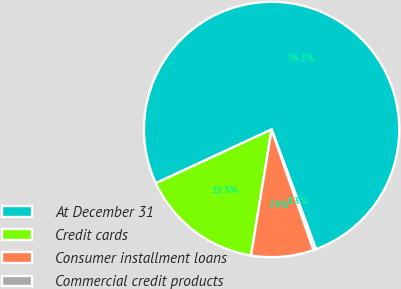Convert chart to OTSL. <chart><loc_0><loc_0><loc_500><loc_500><pie_chart><fcel>At December 31<fcel>Credit cards<fcel>Consumer installment loans<fcel>Commercial credit products<nl><fcel>76.26%<fcel>15.51%<fcel>7.91%<fcel>0.32%<nl></chart> 